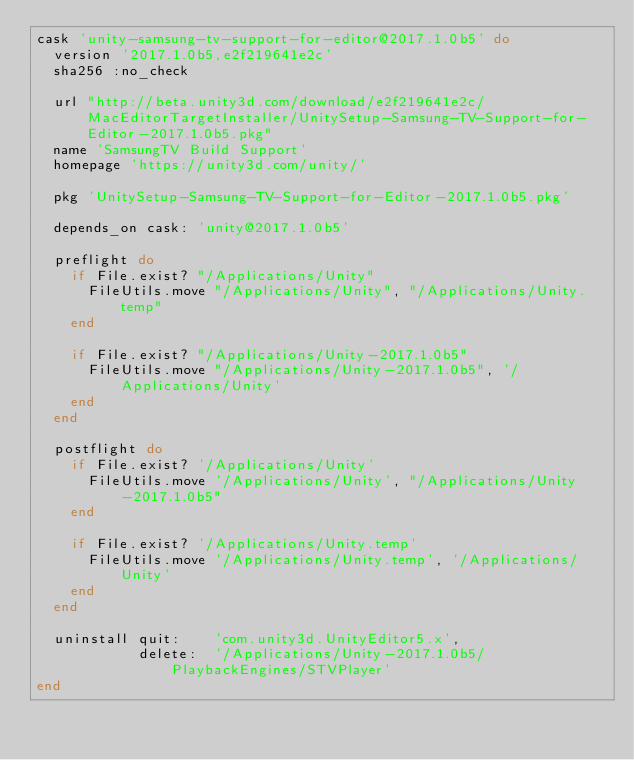<code> <loc_0><loc_0><loc_500><loc_500><_Ruby_>cask 'unity-samsung-tv-support-for-editor@2017.1.0b5' do
  version '2017.1.0b5,e2f219641e2c'
  sha256 :no_check

  url "http://beta.unity3d.com/download/e2f219641e2c/MacEditorTargetInstaller/UnitySetup-Samsung-TV-Support-for-Editor-2017.1.0b5.pkg"
  name 'SamsungTV Build Support'
  homepage 'https://unity3d.com/unity/'

  pkg 'UnitySetup-Samsung-TV-Support-for-Editor-2017.1.0b5.pkg'

  depends_on cask: 'unity@2017.1.0b5'

  preflight do
    if File.exist? "/Applications/Unity"
      FileUtils.move "/Applications/Unity", "/Applications/Unity.temp"
    end

    if File.exist? "/Applications/Unity-2017.1.0b5"
      FileUtils.move "/Applications/Unity-2017.1.0b5", '/Applications/Unity'
    end
  end

  postflight do
    if File.exist? '/Applications/Unity'
      FileUtils.move '/Applications/Unity', "/Applications/Unity-2017.1.0b5"
    end

    if File.exist? '/Applications/Unity.temp'
      FileUtils.move '/Applications/Unity.temp', '/Applications/Unity'
    end
  end

  uninstall quit:    'com.unity3d.UnityEditor5.x',
            delete:  '/Applications/Unity-2017.1.0b5/PlaybackEngines/STVPlayer'
end
</code> 